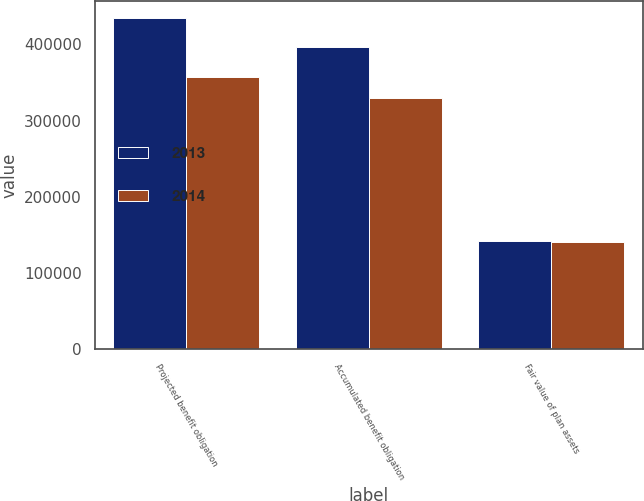Convert chart to OTSL. <chart><loc_0><loc_0><loc_500><loc_500><stacked_bar_chart><ecel><fcel>Projected benefit obligation<fcel>Accumulated benefit obligation<fcel>Fair value of plan assets<nl><fcel>2013<fcel>435124<fcel>397159<fcel>141771<nl><fcel>2014<fcel>357459<fcel>330215<fcel>141186<nl></chart> 